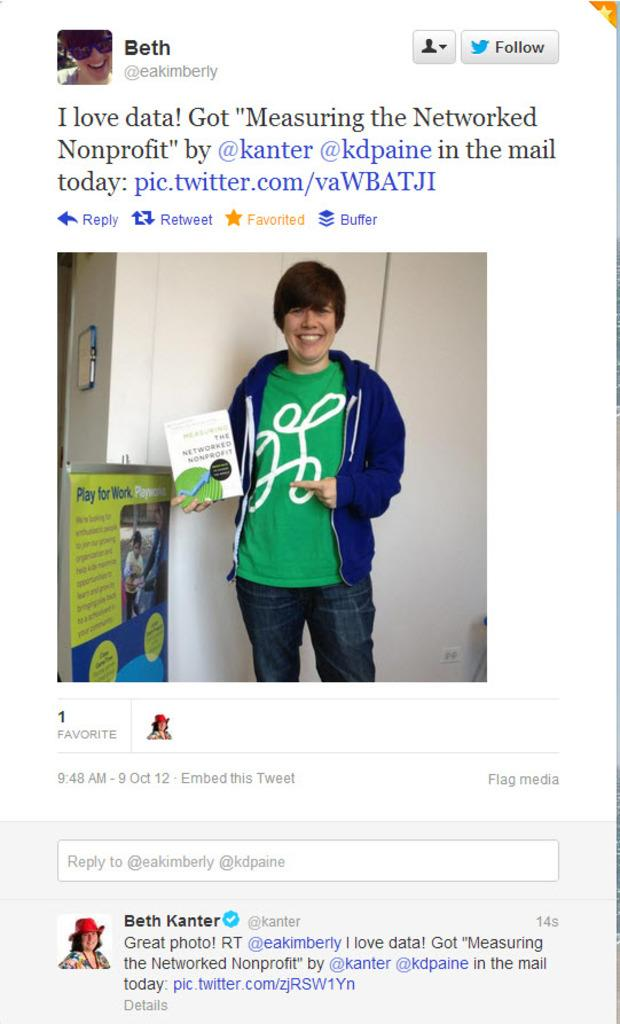Provide a one-sentence caption for the provided image. A twitter page of a twitter creator called Beth concerning a nonprofit. 